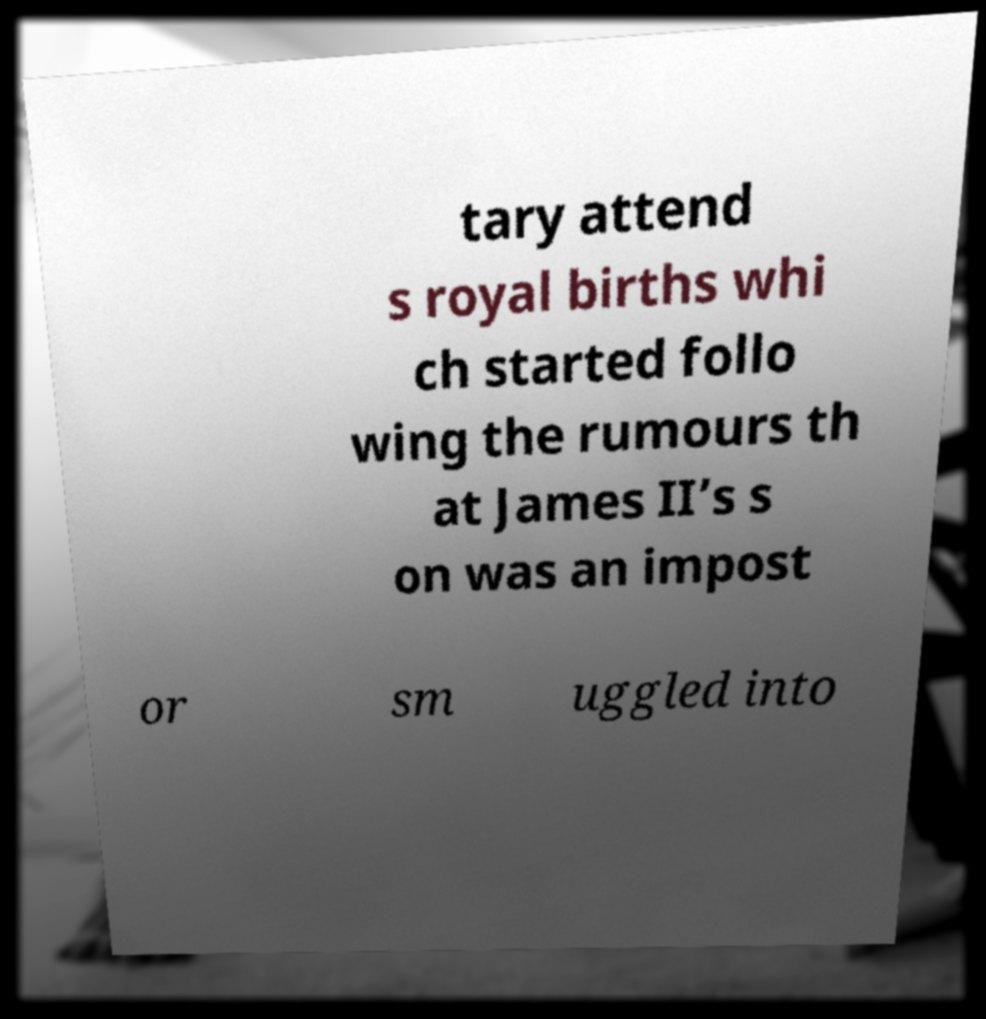Could you assist in decoding the text presented in this image and type it out clearly? tary attend s royal births whi ch started follo wing the rumours th at James II’s s on was an impost or sm uggled into 